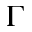Convert formula to latex. <formula><loc_0><loc_0><loc_500><loc_500>\Gamma</formula> 